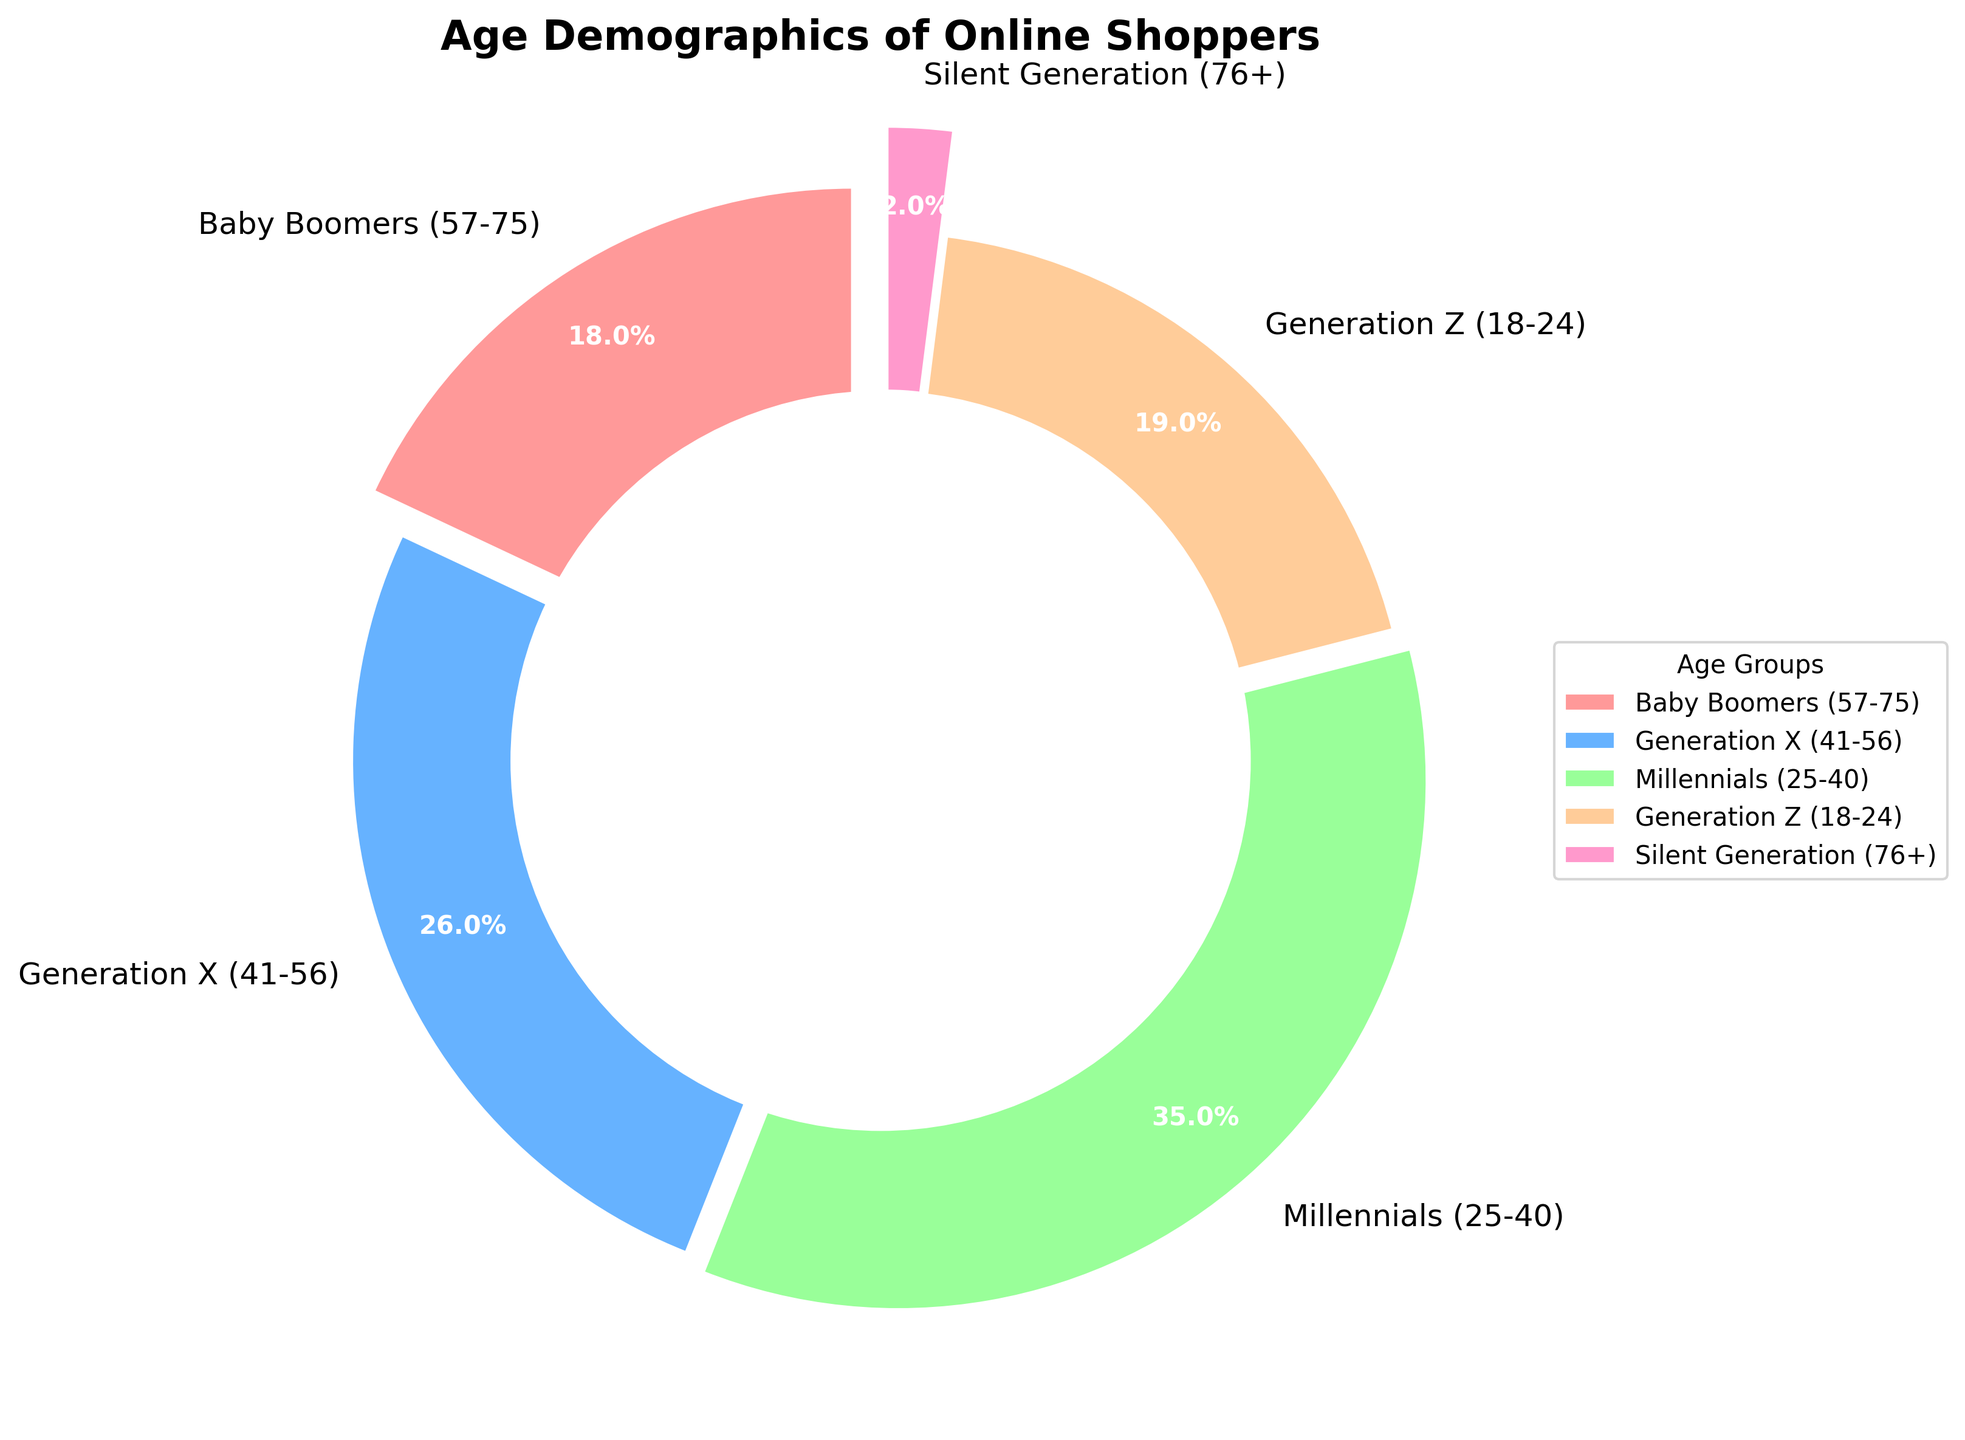What's the largest age group among online shoppers? By looking at the pie chart, the section with the largest percentage corresponds to Millennials (25-40) at 35%. This indicates they are the largest age group among online shoppers.
Answer: Millennials (25-40) What's the combined percentage of Baby Boomers and Generation Z shoppers? The pie chart shows Baby Boomers at 18% and Generation Z at 19%. Adding these two percentages gives 18% + 19% = 37%.
Answer: 37% Which age group has a smaller percentage of online shoppers: Silent Generation or Generation Z? According to the pie chart, Silent Generation has 2%, while Generation Z has 19%. Therefore, Silent Generation has a smaller percentage.
Answer: Silent Generation What's the difference in the percentage of online shoppers between Millennials and Baby Boomers? The pie chart indicates that Millennials have 35% and Baby Boomers have 18%. The difference between these percentages is 35% - 18% = 17%.
Answer: 17% Does Generation X have more or fewer online shoppers compared to Generation Z? The pie chart shows Generation X with 26% and Generation Z with 19%. Therefore, Generation X has more online shoppers.
Answer: More What percentage of the total do Generation X and Millennials together constitute? The pie chart indicates that Generation X is 26% and Millennials are 35%. Adding these, we get 26% + 35% = 61%.
Answer: 61% Which age group is represented by the section that is colored red? Since no code details should be included, and based on visual interpretation, we'd initially refer to the color description to identify that Baby Boomers are colored red with 18%.
Answer: Baby Boomers What's the smallest segment on the pie chart? The pie chart presents the Silent Generation at 2%, which is the smallest segment compared to the others.
Answer: Silent Generation Compare the segment sizes of Millennials and Generation Z. Which is larger and by how much? Millennials are represented with 35% and Generation Z with 19%. Subtract 19% from 35% to find the difference: 35% - 19% = 16%. Therefore, Millennials have a larger segment by 16%.
Answer: Millennials by 16% What is the median percentage value among the age groups? Listing the percentages in order: 2%, 18%, 19%, 26%, 35%. The median value is the middle one, which is 19% (Generation Z).
Answer: 19% 